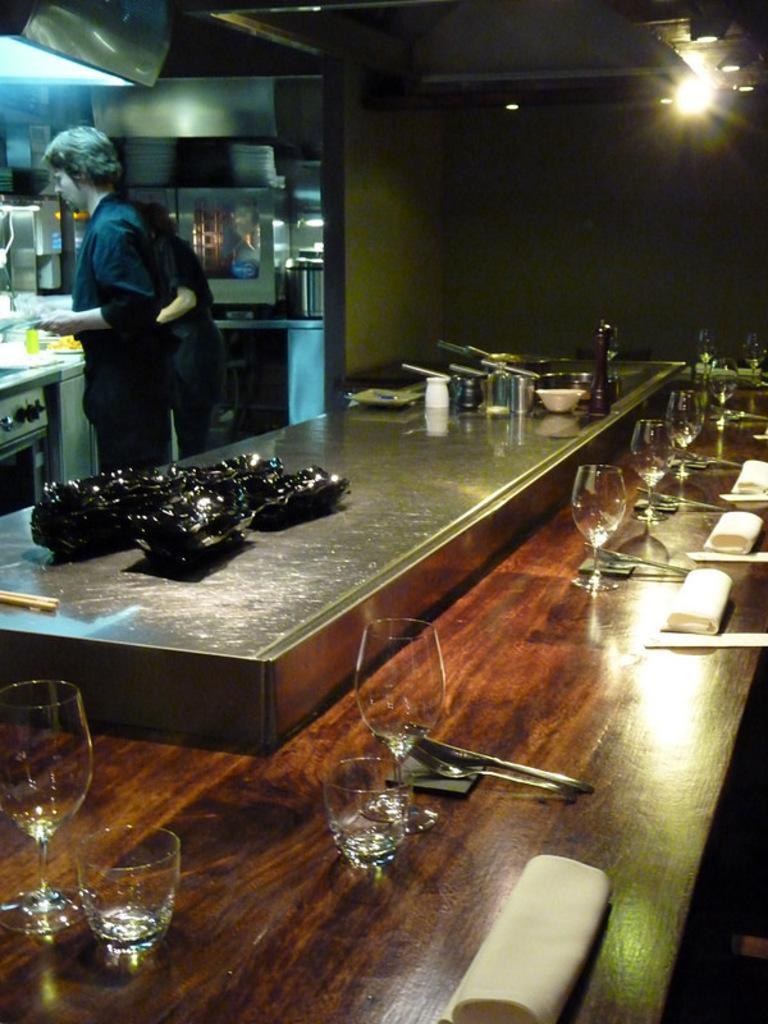In one or two sentences, can you explain what this image depicts? This picture shows kitchen where we see to man standing and we see few glasses and fork and spoon on the table 